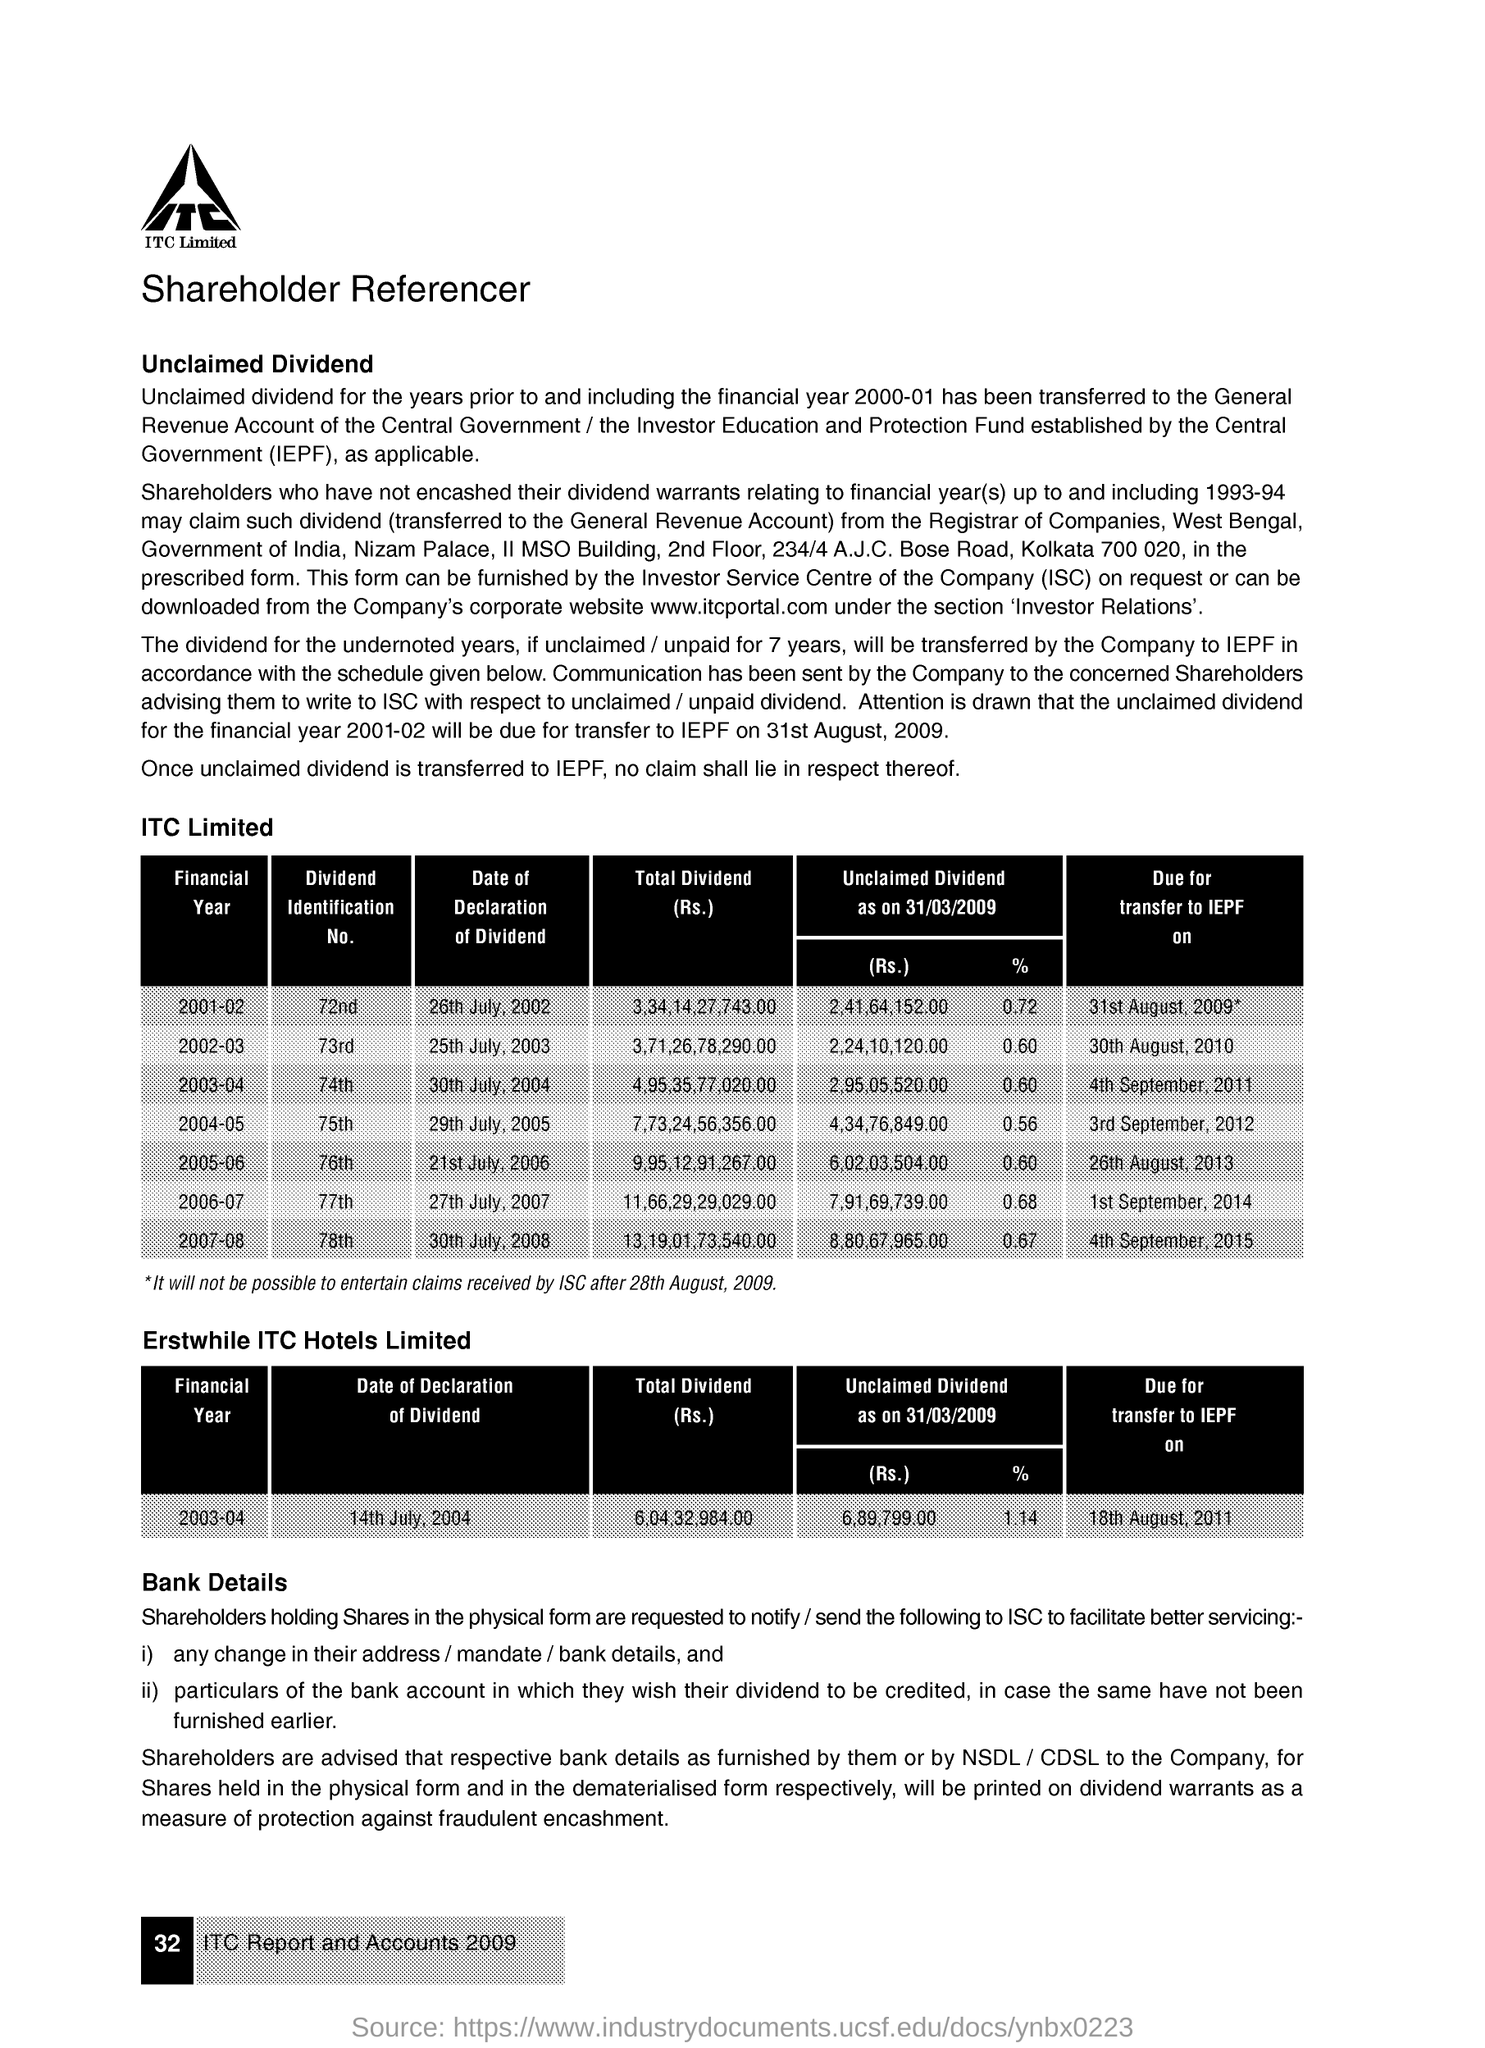What is the rate for the unclaimed dividend as on 31/03/2009 for the financial year 2002-03?
Offer a terse response. 0.60. How much of amount for the unclaimed dividend as on 31/03/2009 for the financial year 2006-07?
Provide a short and direct response. 7,91,69,739.00. What is the dividend identifcation no. for the  financial year 2001-02 ?
Give a very brief answer. 72nd. 